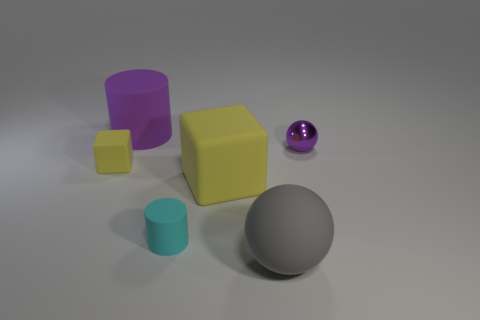There is a rubber thing behind the object that is on the right side of the gray matte sphere; what shape is it?
Give a very brief answer. Cylinder. Is there a cube of the same size as the cyan thing?
Offer a terse response. Yes. How many other rubber things are the same shape as the tiny cyan object?
Your answer should be very brief. 1. Are there the same number of purple balls behind the purple matte cylinder and cyan matte cylinders in front of the cyan object?
Offer a terse response. Yes. Are any purple metal things visible?
Your response must be concise. Yes. What is the size of the yellow thing that is on the right side of the yellow object on the left side of the yellow rubber object that is in front of the tiny yellow rubber object?
Give a very brief answer. Large. There is a yellow object that is the same size as the purple ball; what is its shape?
Offer a terse response. Cube. Are there any other things that have the same material as the tiny yellow object?
Your answer should be very brief. Yes. What number of things are cyan rubber things behind the gray rubber thing or big gray objects?
Provide a short and direct response. 2. There is a small matte thing left of the matte cylinder behind the purple ball; is there a small cyan matte cylinder that is to the left of it?
Provide a succinct answer. No. 